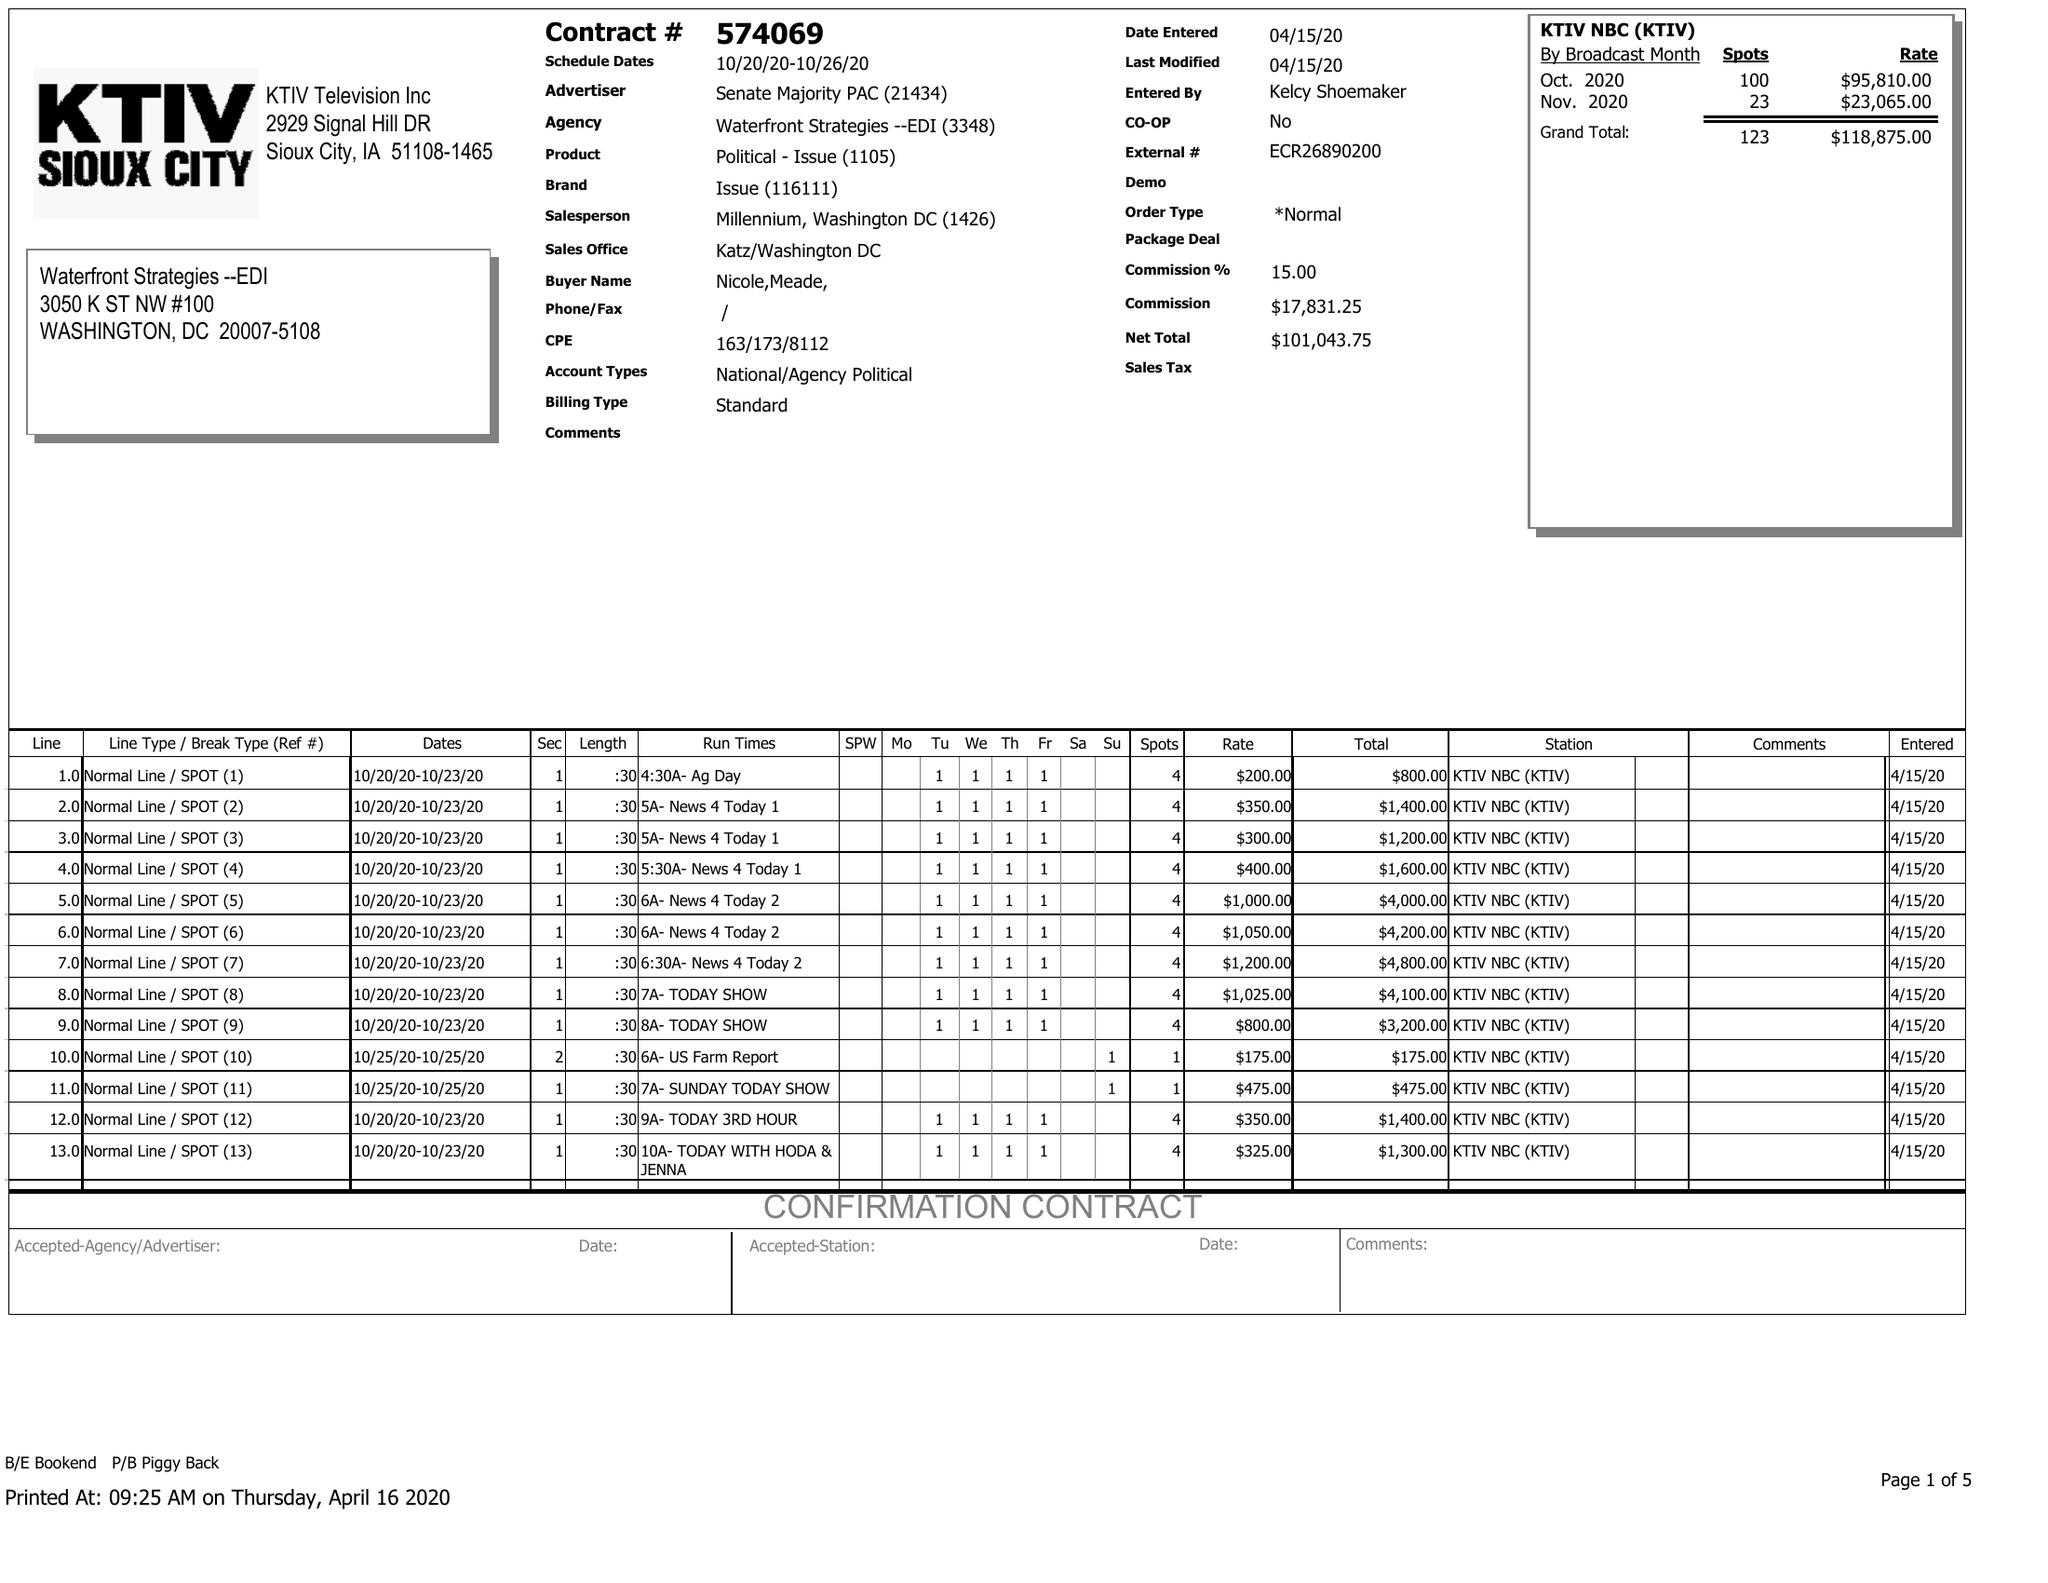What is the value for the gross_amount?
Answer the question using a single word or phrase. 118875.00 